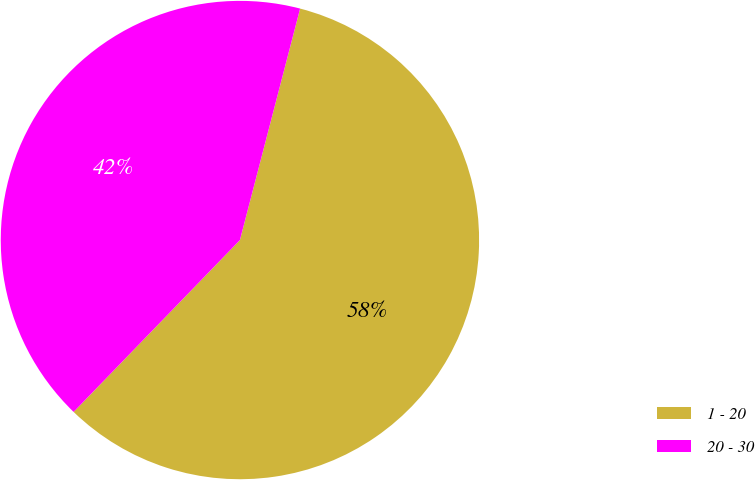<chart> <loc_0><loc_0><loc_500><loc_500><pie_chart><fcel>1 - 20<fcel>20 - 30<nl><fcel>58.19%<fcel>41.81%<nl></chart> 